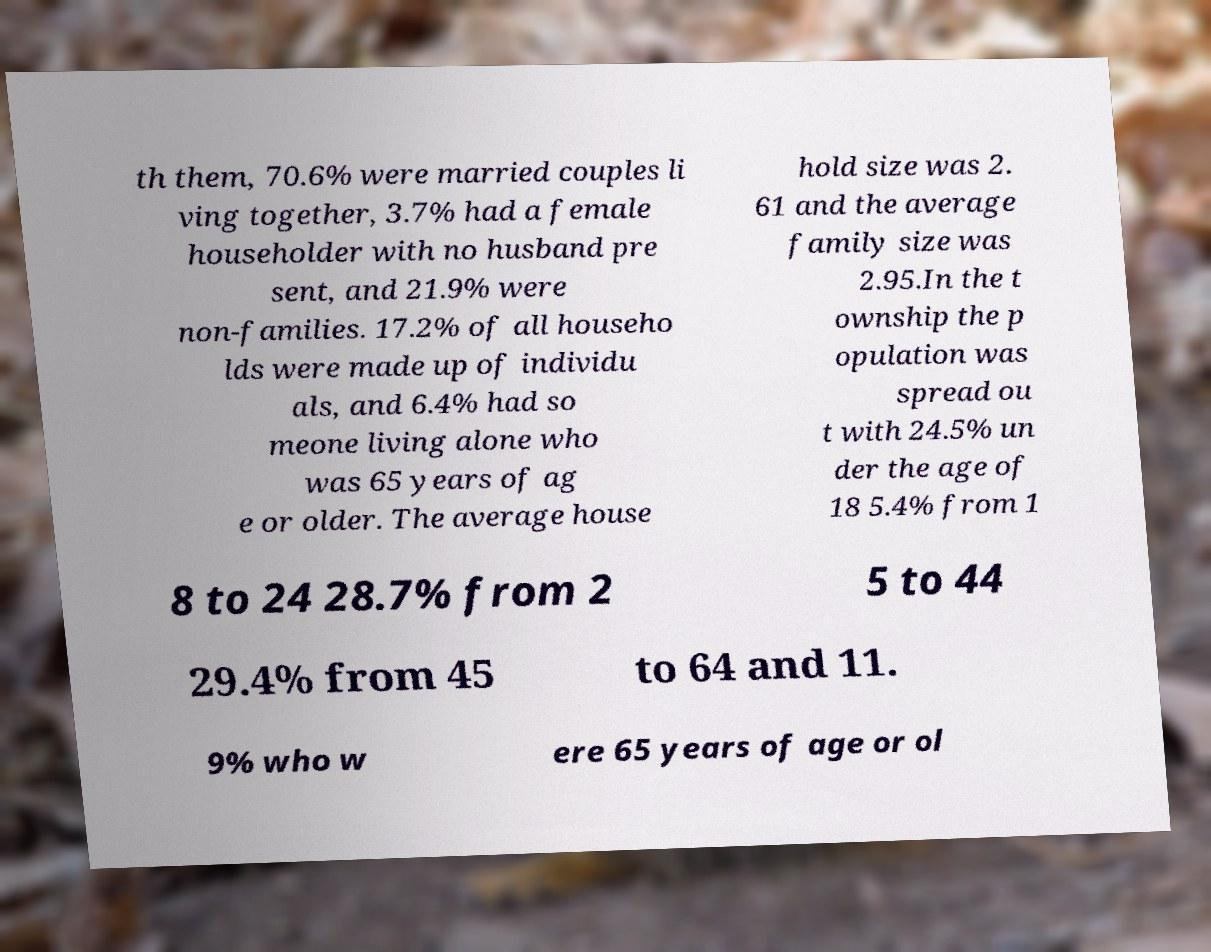Can you read and provide the text displayed in the image?This photo seems to have some interesting text. Can you extract and type it out for me? th them, 70.6% were married couples li ving together, 3.7% had a female householder with no husband pre sent, and 21.9% were non-families. 17.2% of all househo lds were made up of individu als, and 6.4% had so meone living alone who was 65 years of ag e or older. The average house hold size was 2. 61 and the average family size was 2.95.In the t ownship the p opulation was spread ou t with 24.5% un der the age of 18 5.4% from 1 8 to 24 28.7% from 2 5 to 44 29.4% from 45 to 64 and 11. 9% who w ere 65 years of age or ol 